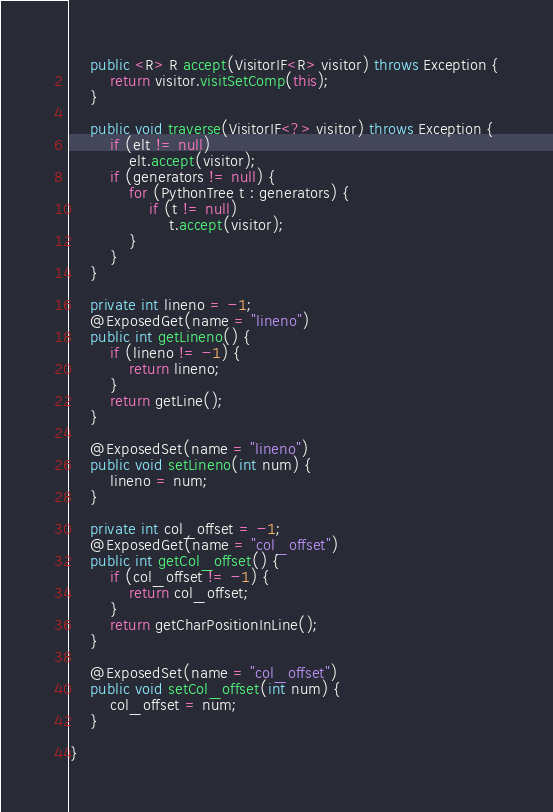<code> <loc_0><loc_0><loc_500><loc_500><_Java_>
    public <R> R accept(VisitorIF<R> visitor) throws Exception {
        return visitor.visitSetComp(this);
    }

    public void traverse(VisitorIF<?> visitor) throws Exception {
        if (elt != null)
            elt.accept(visitor);
        if (generators != null) {
            for (PythonTree t : generators) {
                if (t != null)
                    t.accept(visitor);
            }
        }
    }

    private int lineno = -1;
    @ExposedGet(name = "lineno")
    public int getLineno() {
        if (lineno != -1) {
            return lineno;
        }
        return getLine();
    }

    @ExposedSet(name = "lineno")
    public void setLineno(int num) {
        lineno = num;
    }

    private int col_offset = -1;
    @ExposedGet(name = "col_offset")
    public int getCol_offset() {
        if (col_offset != -1) {
            return col_offset;
        }
        return getCharPositionInLine();
    }

    @ExposedSet(name = "col_offset")
    public void setCol_offset(int num) {
        col_offset = num;
    }

}
</code> 